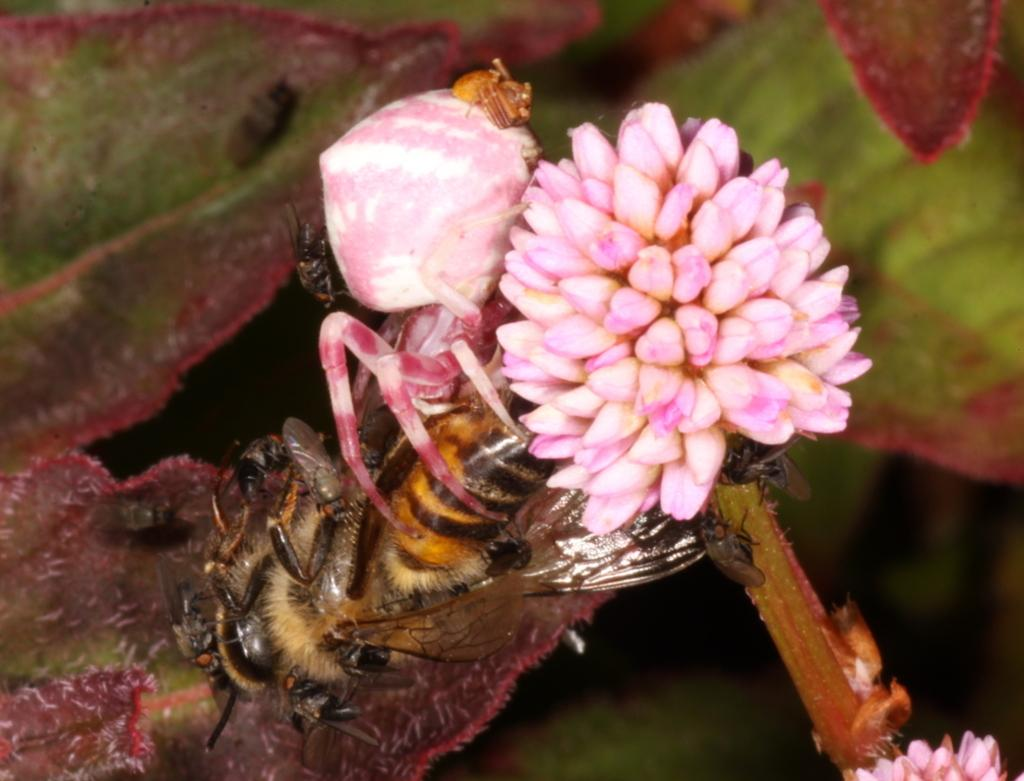What type of plants can be seen in the image? There are flowers in the image. What insect is present in the image? There is a honeybee in the image. Are there any other insects visible in the image? Yes, there are insects in the image. What type of neck accessory is the honeybee wearing in the image? There is no neck accessory present on the honeybee in the image. Can you tell me how many faucets are visible in the image? There are no faucets present in the image. 